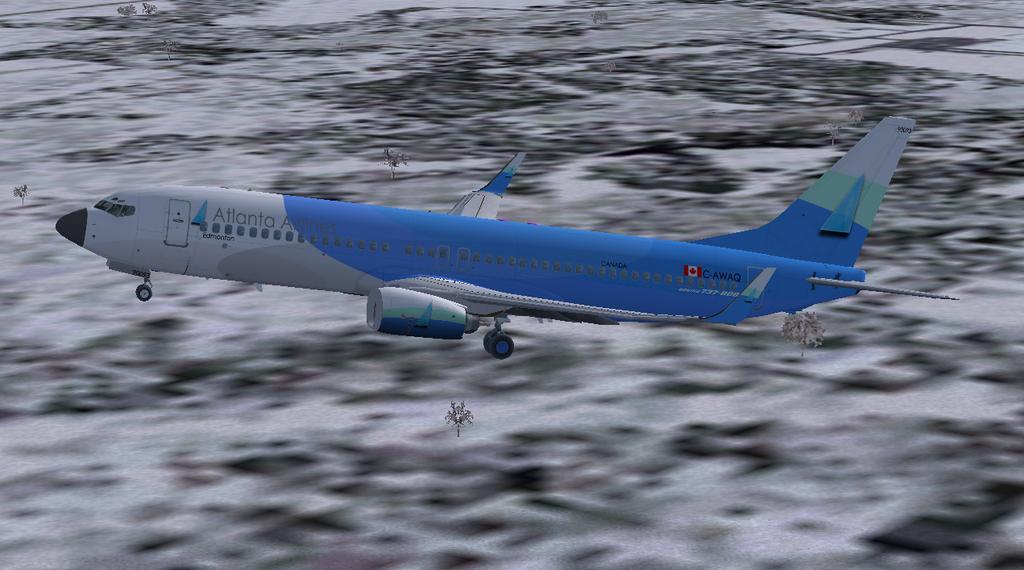How would you summarize this image in a sentence or two? In this image I can see an airplane flying in the air towards the left side. The background is blurred. 